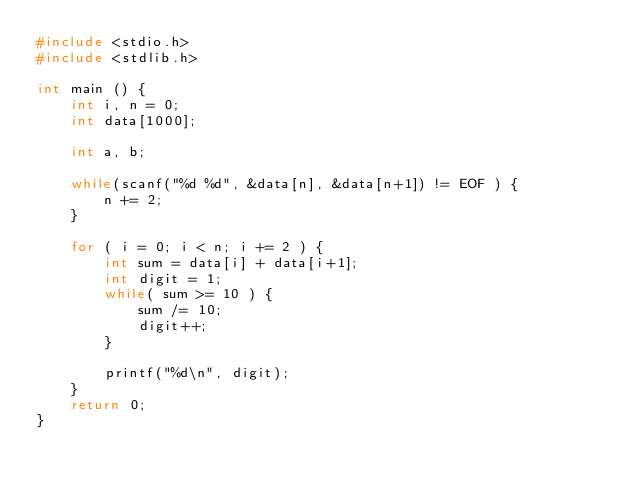Convert code to text. <code><loc_0><loc_0><loc_500><loc_500><_C_>#include <stdio.h>
#include <stdlib.h>

int main () {
    int i, n = 0;
    int data[1000];

    int a, b;

    while(scanf("%d %d", &data[n], &data[n+1]) != EOF ) {
        n += 2;
    }

    for ( i = 0; i < n; i += 2 ) {
        int sum = data[i] + data[i+1];
        int digit = 1;
        while( sum >= 10 ) {
            sum /= 10;
            digit++;
        }

        printf("%d\n", digit);
    }
    return 0;
}</code> 